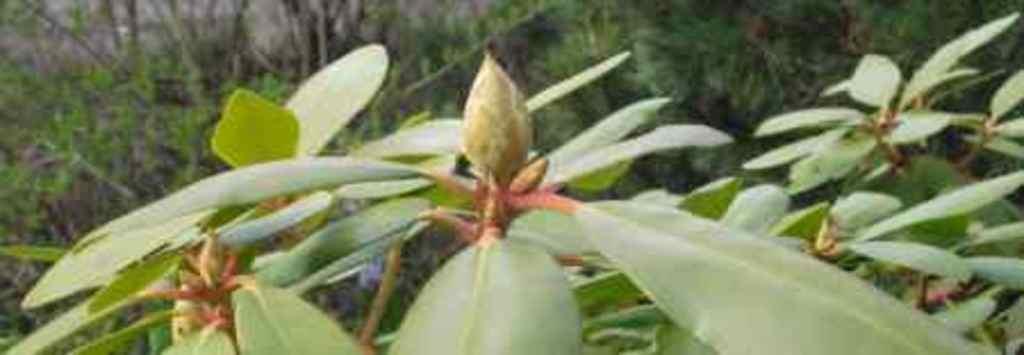Please provide a concise description of this image. In the foreground of the image there are leaves. In the background of the image there are trees. 